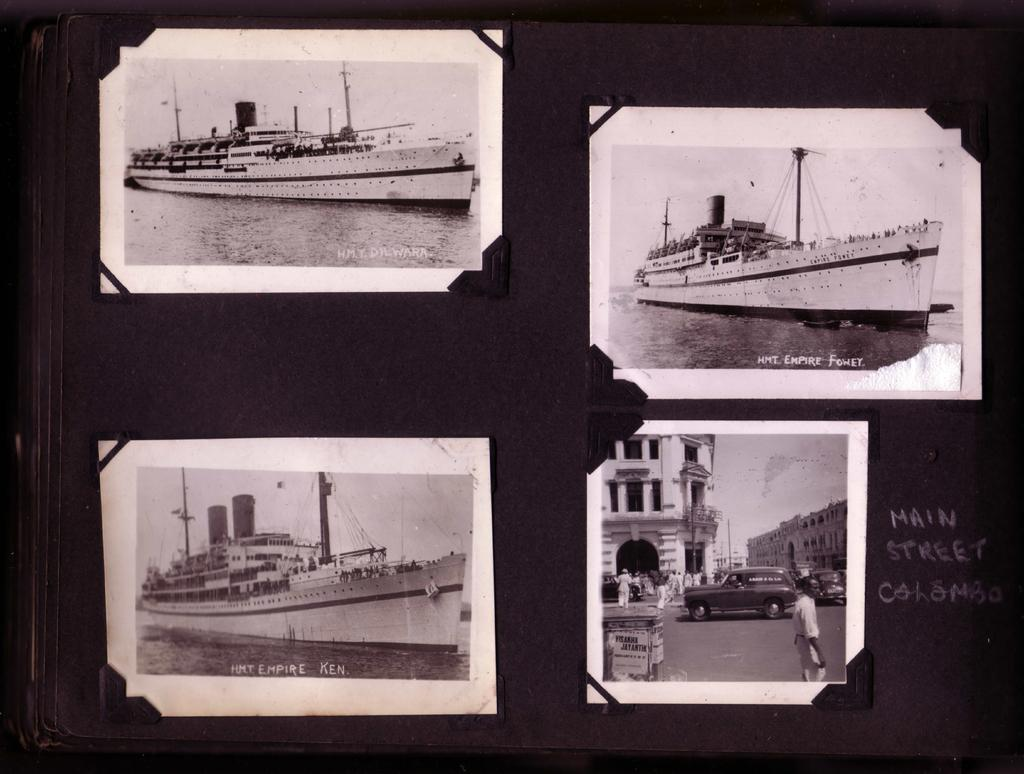What is displayed on the board in the image? There are photographs and text on the board. What subjects are depicted in the photographs on the board? The photographs depict ships, buildings, vehicles, people, water, and sky. What emotion does the disgusting smell emanating from the board evoke in the viewer? There is no mention of any smell or emotion in the image, so it cannot be determined from the image. 